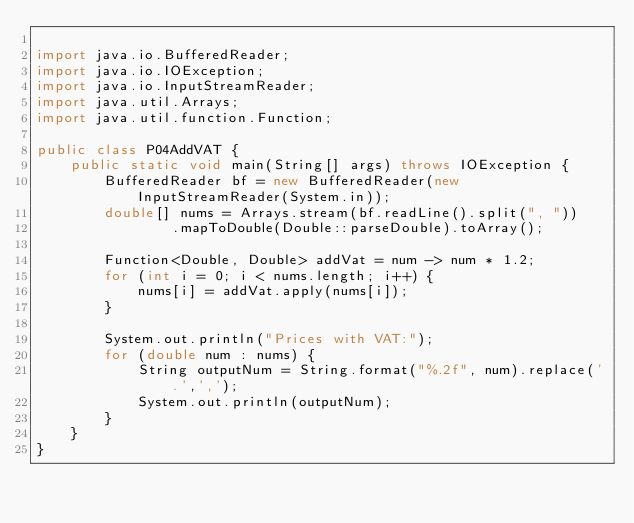<code> <loc_0><loc_0><loc_500><loc_500><_Java_>
import java.io.BufferedReader;
import java.io.IOException;
import java.io.InputStreamReader;
import java.util.Arrays;
import java.util.function.Function;

public class P04AddVAT {
    public static void main(String[] args) throws IOException {
        BufferedReader bf = new BufferedReader(new InputStreamReader(System.in));
        double[] nums = Arrays.stream(bf.readLine().split(", "))
                .mapToDouble(Double::parseDouble).toArray();

        Function<Double, Double> addVat = num -> num * 1.2;
        for (int i = 0; i < nums.length; i++) {
            nums[i] = addVat.apply(nums[i]);
        }

        System.out.println("Prices with VAT:");
        for (double num : nums) {
            String outputNum = String.format("%.2f", num).replace('.',',');
            System.out.println(outputNum);
        }
    }
}
</code> 